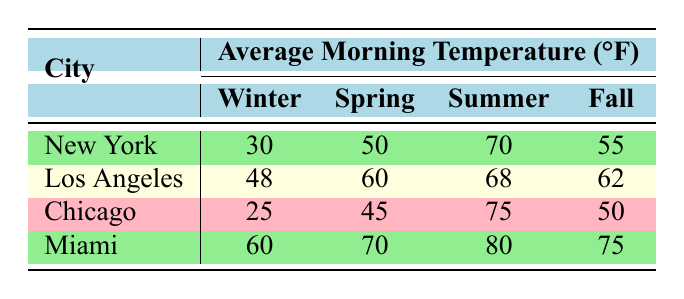What is the average morning temperature in New York during summer? The table indicates that the average morning temperature in New York during summer is 70°F.
Answer: 70°F Which city has the lowest average morning temperature in winter? By examining the winter temperatures for each city in the table: New York (30°F), Los Angeles (48°F), Chicago (25°F), and Miami (60°F), Chicago has the lowest temperature at 25°F.
Answer: Chicago What is the average morning temperature in Miami across all seasons? The average morning temperatures in Miami are: Winter (60°F), Spring (70°F), Summer (80°F), Fall (75°F). To find the average: (60 + 70 + 80 + 75)/4 = 71.25°F.
Answer: 71.25°F Is it true that Los Angeles has a higher average morning temperature in spring than Chicago? For Spring, Los Angeles has an average temperature of 60°F, while Chicago has 45°F. Since 60°F is greater than 45°F, the statement is true.
Answer: Yes What is the difference in average morning temperature between summer and winter in New York? The average morning temperature in New York for summer is 70°F and for winter is 30°F. The difference is calculated as 70°F - 30°F = 40°F.
Answer: 40°F What is the average morning temperature in the fall for Los Angeles and Miami combined? The average temperatures for Fall are: Los Angeles (62°F) and Miami (75°F). To find the combined average: (62 + 75)/2 = 68.5°F.
Answer: 68.5°F Which city has the highest average morning temperature in summer? In the summer, the average temperatures are: New York (70°F), Los Angeles (68°F), Chicago (75°F), and Miami (80°F). Miami has the highest average temperature at 80°F.
Answer: Miami Does Chicago have a warmer average morning temperature in any season compared to Los Angeles? By comparing the temperatures: Winter (Chicago 25°F vs. Los Angeles 48°F), Spring (Chicago 45°F vs. Los Angeles 60°F), Summer (Chicago 75°F vs. Los Angeles 68°F), and Fall (Chicago 50°F vs. Los Angeles 62°F), Chicago is warmer only in summer, so the answer is yes.
Answer: Yes 